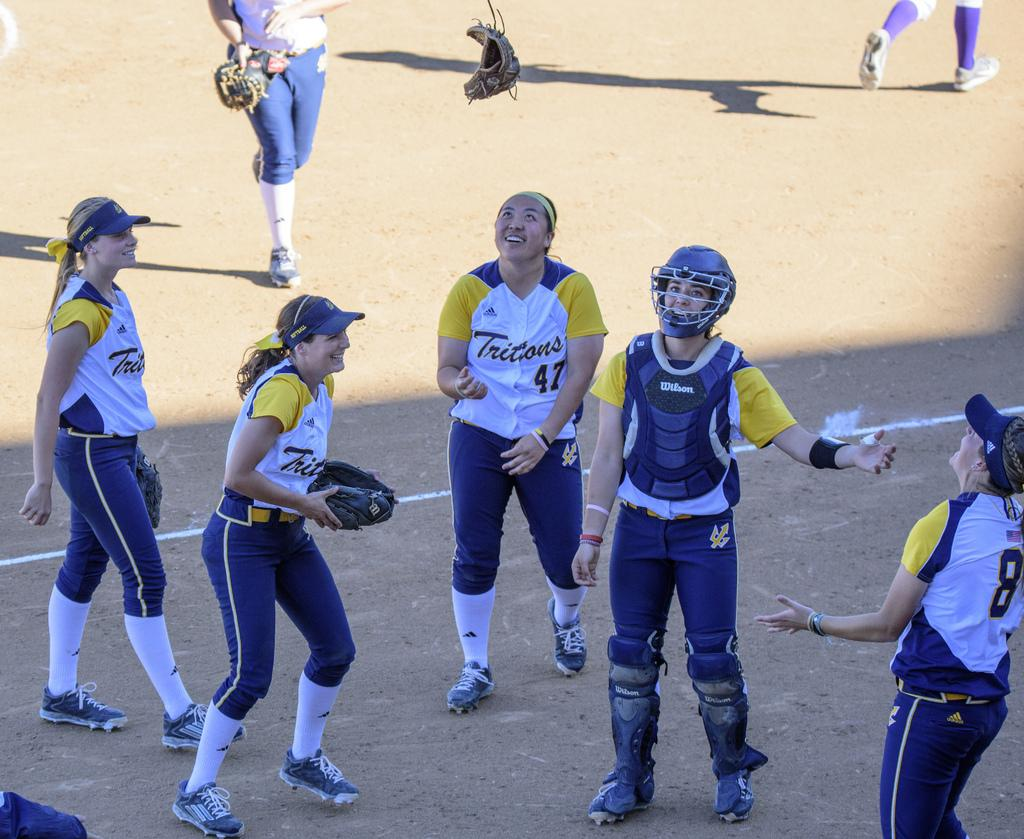<image>
Share a concise interpretation of the image provided. Players from the Tritons team  are talking and looking up in the air. 